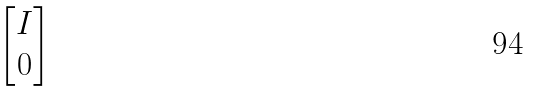Convert formula to latex. <formula><loc_0><loc_0><loc_500><loc_500>\begin{bmatrix} I \\ 0 \end{bmatrix}</formula> 